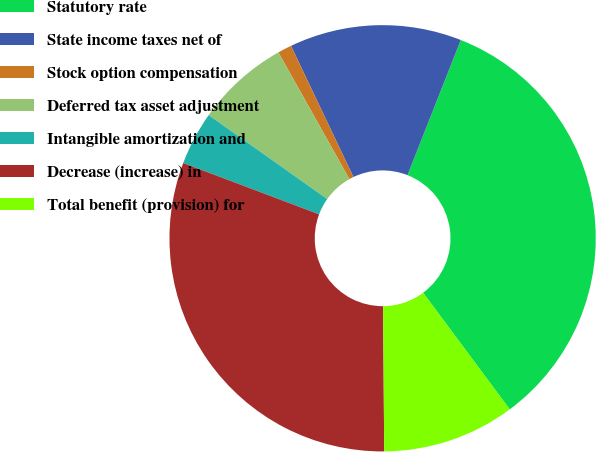Convert chart to OTSL. <chart><loc_0><loc_0><loc_500><loc_500><pie_chart><fcel>Statutory rate<fcel>State income taxes net of<fcel>Stock option compensation<fcel>Deferred tax asset adjustment<fcel>Intangible amortization and<fcel>Decrease (increase) in<fcel>Total benefit (provision) for<nl><fcel>33.85%<fcel>13.05%<fcel>1.06%<fcel>7.06%<fcel>4.06%<fcel>30.86%<fcel>10.05%<nl></chart> 